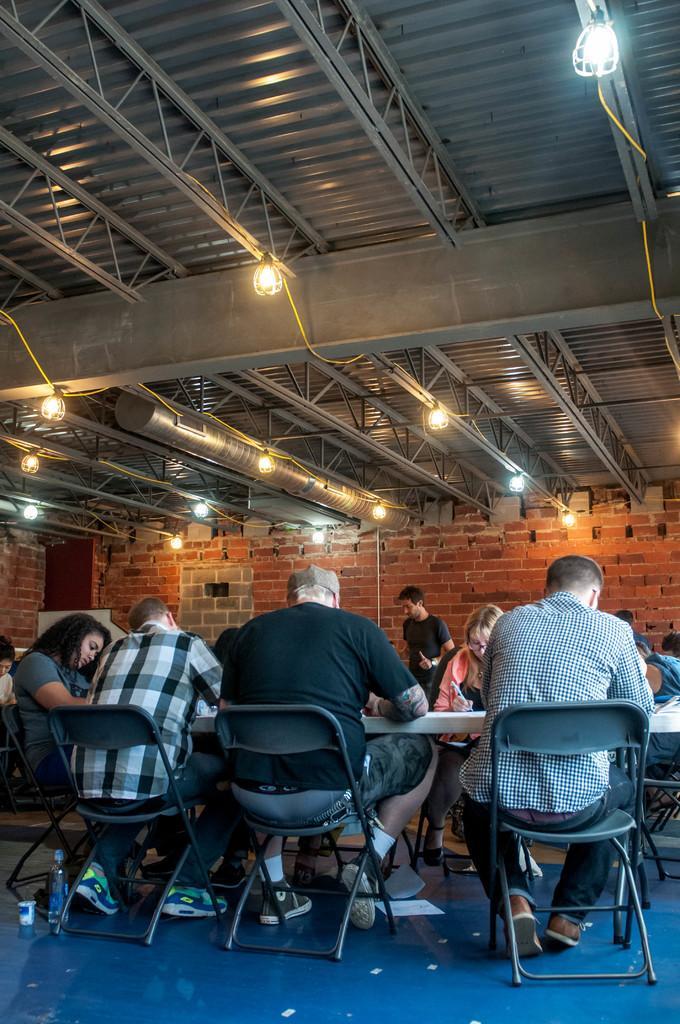Please provide a concise description of this image. In the picture there are few people sitting around a table,behind them there is a brick wall,to the roof of there is an iron railing to that there are some lights held. 